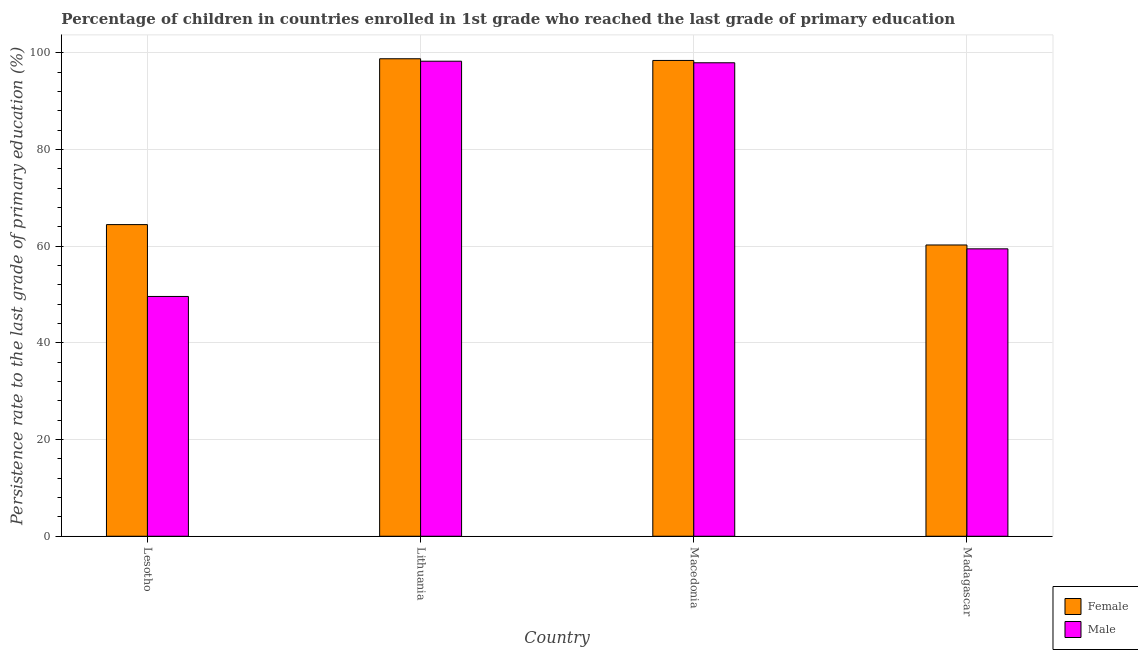How many groups of bars are there?
Provide a succinct answer. 4. Are the number of bars per tick equal to the number of legend labels?
Give a very brief answer. Yes. Are the number of bars on each tick of the X-axis equal?
Provide a short and direct response. Yes. How many bars are there on the 4th tick from the right?
Offer a very short reply. 2. What is the label of the 1st group of bars from the left?
Make the answer very short. Lesotho. In how many cases, is the number of bars for a given country not equal to the number of legend labels?
Make the answer very short. 0. What is the persistence rate of female students in Lithuania?
Make the answer very short. 98.79. Across all countries, what is the maximum persistence rate of male students?
Provide a succinct answer. 98.29. Across all countries, what is the minimum persistence rate of male students?
Offer a very short reply. 49.61. In which country was the persistence rate of female students maximum?
Give a very brief answer. Lithuania. In which country was the persistence rate of female students minimum?
Make the answer very short. Madagascar. What is the total persistence rate of male students in the graph?
Your answer should be compact. 305.33. What is the difference between the persistence rate of male students in Lesotho and that in Madagascar?
Offer a terse response. -9.85. What is the difference between the persistence rate of male students in Lesotho and the persistence rate of female students in Madagascar?
Give a very brief answer. -10.65. What is the average persistence rate of male students per country?
Ensure brevity in your answer.  76.33. What is the difference between the persistence rate of male students and persistence rate of female students in Lesotho?
Your response must be concise. -14.87. In how many countries, is the persistence rate of male students greater than 56 %?
Provide a succinct answer. 3. What is the ratio of the persistence rate of female students in Lesotho to that in Madagascar?
Your answer should be very brief. 1.07. Is the persistence rate of male students in Macedonia less than that in Madagascar?
Your answer should be very brief. No. Is the difference between the persistence rate of male students in Lesotho and Macedonia greater than the difference between the persistence rate of female students in Lesotho and Macedonia?
Your answer should be compact. No. What is the difference between the highest and the second highest persistence rate of male students?
Offer a very short reply. 0.32. What is the difference between the highest and the lowest persistence rate of female students?
Give a very brief answer. 38.53. In how many countries, is the persistence rate of male students greater than the average persistence rate of male students taken over all countries?
Provide a succinct answer. 2. Is the sum of the persistence rate of male students in Macedonia and Madagascar greater than the maximum persistence rate of female students across all countries?
Your response must be concise. Yes. What does the 1st bar from the left in Lesotho represents?
Give a very brief answer. Female. How many bars are there?
Offer a very short reply. 8. What is the difference between two consecutive major ticks on the Y-axis?
Your answer should be compact. 20. Are the values on the major ticks of Y-axis written in scientific E-notation?
Keep it short and to the point. No. Does the graph contain grids?
Your answer should be very brief. Yes. Where does the legend appear in the graph?
Your answer should be very brief. Bottom right. How many legend labels are there?
Your answer should be very brief. 2. How are the legend labels stacked?
Provide a succinct answer. Vertical. What is the title of the graph?
Offer a terse response. Percentage of children in countries enrolled in 1st grade who reached the last grade of primary education. What is the label or title of the Y-axis?
Offer a terse response. Persistence rate to the last grade of primary education (%). What is the Persistence rate to the last grade of primary education (%) in Female in Lesotho?
Your response must be concise. 64.48. What is the Persistence rate to the last grade of primary education (%) of Male in Lesotho?
Offer a very short reply. 49.61. What is the Persistence rate to the last grade of primary education (%) of Female in Lithuania?
Provide a succinct answer. 98.79. What is the Persistence rate to the last grade of primary education (%) of Male in Lithuania?
Your answer should be very brief. 98.29. What is the Persistence rate to the last grade of primary education (%) of Female in Macedonia?
Keep it short and to the point. 98.44. What is the Persistence rate to the last grade of primary education (%) in Male in Macedonia?
Provide a succinct answer. 97.96. What is the Persistence rate to the last grade of primary education (%) in Female in Madagascar?
Provide a succinct answer. 60.26. What is the Persistence rate to the last grade of primary education (%) of Male in Madagascar?
Your answer should be compact. 59.47. Across all countries, what is the maximum Persistence rate to the last grade of primary education (%) of Female?
Provide a succinct answer. 98.79. Across all countries, what is the maximum Persistence rate to the last grade of primary education (%) of Male?
Your answer should be compact. 98.29. Across all countries, what is the minimum Persistence rate to the last grade of primary education (%) in Female?
Keep it short and to the point. 60.26. Across all countries, what is the minimum Persistence rate to the last grade of primary education (%) in Male?
Ensure brevity in your answer.  49.61. What is the total Persistence rate to the last grade of primary education (%) of Female in the graph?
Give a very brief answer. 321.98. What is the total Persistence rate to the last grade of primary education (%) in Male in the graph?
Provide a short and direct response. 305.33. What is the difference between the Persistence rate to the last grade of primary education (%) in Female in Lesotho and that in Lithuania?
Offer a very short reply. -34.31. What is the difference between the Persistence rate to the last grade of primary education (%) in Male in Lesotho and that in Lithuania?
Give a very brief answer. -48.67. What is the difference between the Persistence rate to the last grade of primary education (%) in Female in Lesotho and that in Macedonia?
Provide a short and direct response. -33.96. What is the difference between the Persistence rate to the last grade of primary education (%) of Male in Lesotho and that in Macedonia?
Provide a succinct answer. -48.35. What is the difference between the Persistence rate to the last grade of primary education (%) in Female in Lesotho and that in Madagascar?
Offer a terse response. 4.22. What is the difference between the Persistence rate to the last grade of primary education (%) of Male in Lesotho and that in Madagascar?
Give a very brief answer. -9.85. What is the difference between the Persistence rate to the last grade of primary education (%) in Female in Lithuania and that in Macedonia?
Provide a succinct answer. 0.35. What is the difference between the Persistence rate to the last grade of primary education (%) of Male in Lithuania and that in Macedonia?
Ensure brevity in your answer.  0.32. What is the difference between the Persistence rate to the last grade of primary education (%) of Female in Lithuania and that in Madagascar?
Offer a very short reply. 38.53. What is the difference between the Persistence rate to the last grade of primary education (%) in Male in Lithuania and that in Madagascar?
Provide a short and direct response. 38.82. What is the difference between the Persistence rate to the last grade of primary education (%) of Female in Macedonia and that in Madagascar?
Offer a very short reply. 38.18. What is the difference between the Persistence rate to the last grade of primary education (%) of Male in Macedonia and that in Madagascar?
Your answer should be very brief. 38.5. What is the difference between the Persistence rate to the last grade of primary education (%) of Female in Lesotho and the Persistence rate to the last grade of primary education (%) of Male in Lithuania?
Offer a very short reply. -33.81. What is the difference between the Persistence rate to the last grade of primary education (%) of Female in Lesotho and the Persistence rate to the last grade of primary education (%) of Male in Macedonia?
Provide a succinct answer. -33.48. What is the difference between the Persistence rate to the last grade of primary education (%) of Female in Lesotho and the Persistence rate to the last grade of primary education (%) of Male in Madagascar?
Offer a very short reply. 5.01. What is the difference between the Persistence rate to the last grade of primary education (%) of Female in Lithuania and the Persistence rate to the last grade of primary education (%) of Male in Macedonia?
Ensure brevity in your answer.  0.83. What is the difference between the Persistence rate to the last grade of primary education (%) of Female in Lithuania and the Persistence rate to the last grade of primary education (%) of Male in Madagascar?
Your answer should be very brief. 39.33. What is the difference between the Persistence rate to the last grade of primary education (%) in Female in Macedonia and the Persistence rate to the last grade of primary education (%) in Male in Madagascar?
Your response must be concise. 38.98. What is the average Persistence rate to the last grade of primary education (%) in Female per country?
Your answer should be compact. 80.5. What is the average Persistence rate to the last grade of primary education (%) of Male per country?
Your answer should be very brief. 76.33. What is the difference between the Persistence rate to the last grade of primary education (%) of Female and Persistence rate to the last grade of primary education (%) of Male in Lesotho?
Your response must be concise. 14.87. What is the difference between the Persistence rate to the last grade of primary education (%) of Female and Persistence rate to the last grade of primary education (%) of Male in Lithuania?
Offer a terse response. 0.51. What is the difference between the Persistence rate to the last grade of primary education (%) of Female and Persistence rate to the last grade of primary education (%) of Male in Macedonia?
Provide a succinct answer. 0.48. What is the difference between the Persistence rate to the last grade of primary education (%) in Female and Persistence rate to the last grade of primary education (%) in Male in Madagascar?
Make the answer very short. 0.8. What is the ratio of the Persistence rate to the last grade of primary education (%) of Female in Lesotho to that in Lithuania?
Give a very brief answer. 0.65. What is the ratio of the Persistence rate to the last grade of primary education (%) in Male in Lesotho to that in Lithuania?
Make the answer very short. 0.5. What is the ratio of the Persistence rate to the last grade of primary education (%) of Female in Lesotho to that in Macedonia?
Your response must be concise. 0.66. What is the ratio of the Persistence rate to the last grade of primary education (%) in Male in Lesotho to that in Macedonia?
Make the answer very short. 0.51. What is the ratio of the Persistence rate to the last grade of primary education (%) of Female in Lesotho to that in Madagascar?
Keep it short and to the point. 1.07. What is the ratio of the Persistence rate to the last grade of primary education (%) in Male in Lesotho to that in Madagascar?
Ensure brevity in your answer.  0.83. What is the ratio of the Persistence rate to the last grade of primary education (%) of Male in Lithuania to that in Macedonia?
Your answer should be very brief. 1. What is the ratio of the Persistence rate to the last grade of primary education (%) of Female in Lithuania to that in Madagascar?
Your response must be concise. 1.64. What is the ratio of the Persistence rate to the last grade of primary education (%) of Male in Lithuania to that in Madagascar?
Give a very brief answer. 1.65. What is the ratio of the Persistence rate to the last grade of primary education (%) of Female in Macedonia to that in Madagascar?
Offer a very short reply. 1.63. What is the ratio of the Persistence rate to the last grade of primary education (%) in Male in Macedonia to that in Madagascar?
Your response must be concise. 1.65. What is the difference between the highest and the second highest Persistence rate to the last grade of primary education (%) in Female?
Offer a terse response. 0.35. What is the difference between the highest and the second highest Persistence rate to the last grade of primary education (%) in Male?
Your answer should be compact. 0.32. What is the difference between the highest and the lowest Persistence rate to the last grade of primary education (%) of Female?
Provide a succinct answer. 38.53. What is the difference between the highest and the lowest Persistence rate to the last grade of primary education (%) in Male?
Ensure brevity in your answer.  48.67. 